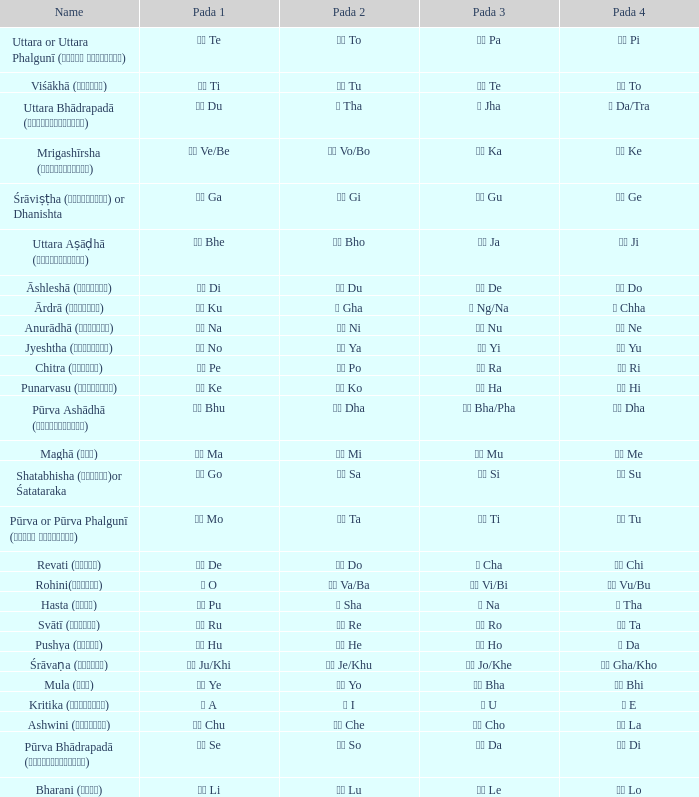Which Pada 3 has a Pada 1 of टे te? पा Pa. 